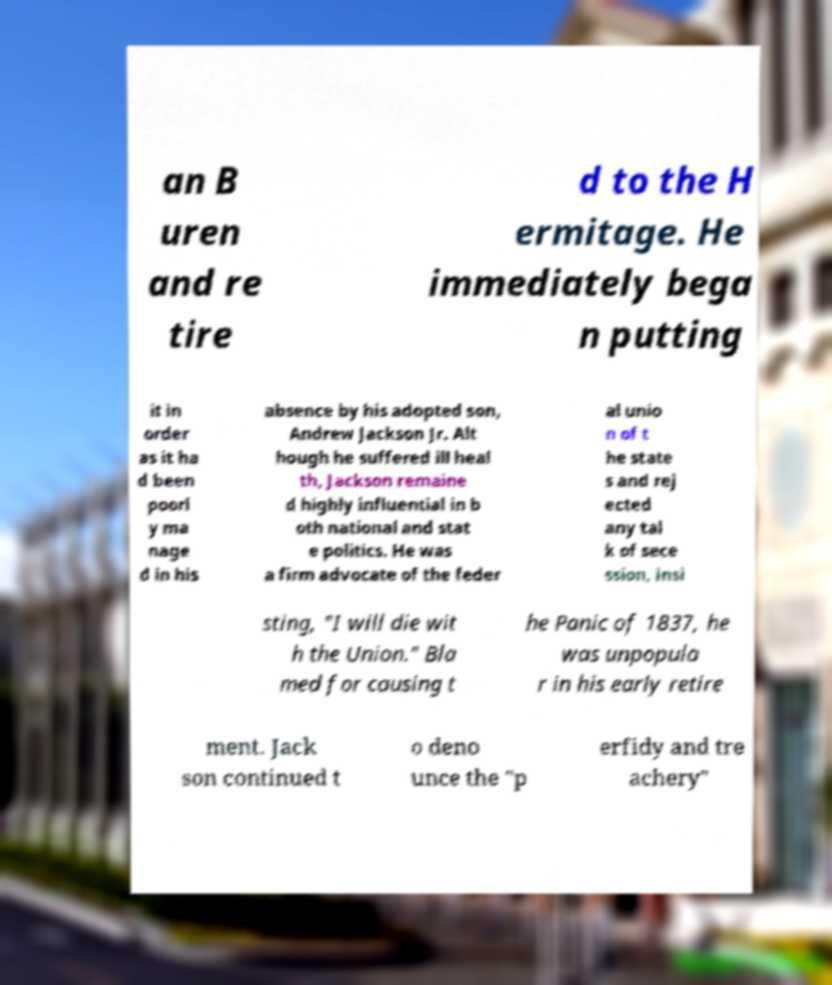I need the written content from this picture converted into text. Can you do that? an B uren and re tire d to the H ermitage. He immediately bega n putting it in order as it ha d been poorl y ma nage d in his absence by his adopted son, Andrew Jackson Jr. Alt hough he suffered ill heal th, Jackson remaine d highly influential in b oth national and stat e politics. He was a firm advocate of the feder al unio n of t he state s and rej ected any tal k of sece ssion, insi sting, "I will die wit h the Union." Bla med for causing t he Panic of 1837, he was unpopula r in his early retire ment. Jack son continued t o deno unce the "p erfidy and tre achery" 